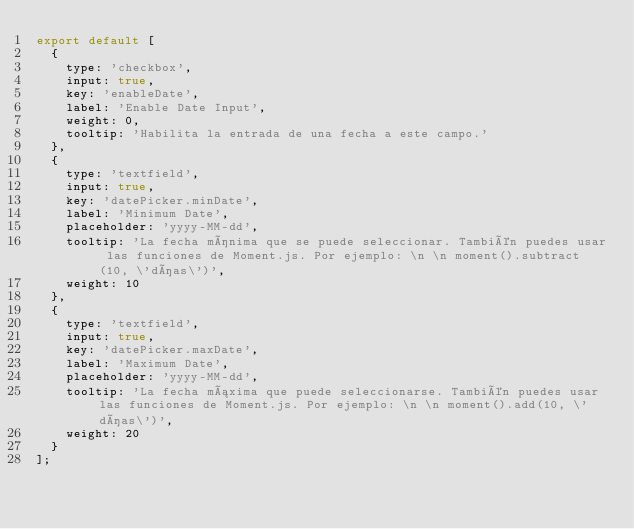<code> <loc_0><loc_0><loc_500><loc_500><_JavaScript_>export default [
  {
    type: 'checkbox',
    input: true,
    key: 'enableDate',
    label: 'Enable Date Input',
    weight: 0,
    tooltip: 'Habilita la entrada de una fecha a este campo.'
  },
  {
    type: 'textfield',
    input: true,
    key: 'datePicker.minDate',
    label: 'Minimum Date',
    placeholder: 'yyyy-MM-dd',
    tooltip: 'La fecha mínima que se puede seleccionar. También puedes usar las funciones de Moment.js. Por ejemplo: \n \n moment().subtract(10, \'días\')',
    weight: 10
  },
  {
    type: 'textfield',
    input: true,
    key: 'datePicker.maxDate',
    label: 'Maximum Date',
    placeholder: 'yyyy-MM-dd',
    tooltip: 'La fecha máxima que puede seleccionarse. También puedes usar las funciones de Moment.js. Por ejemplo: \n \n moment().add(10, \'días\')',
    weight: 20
  }
];
</code> 